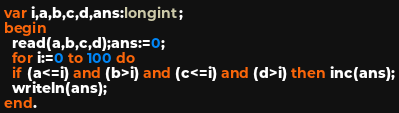<code> <loc_0><loc_0><loc_500><loc_500><_Pascal_>var i,a,b,c,d,ans:longint;
begin
  read(a,b,c,d);ans:=0;
  for i:=0 to 100 do
  if (a<=i) and (b>i) and (c<=i) and (d>i) then inc(ans);
  writeln(ans);
end.</code> 